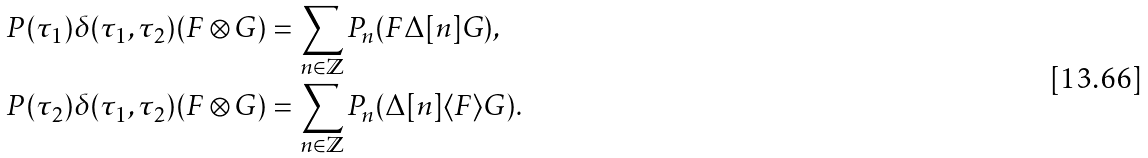<formula> <loc_0><loc_0><loc_500><loc_500>P ( \tau _ { 1 } ) \delta ( \tau _ { 1 } , \tau _ { 2 } ) ( F \otimes G ) & = \sum _ { n \in \mathbb { Z } } P _ { n } ( F \Delta [ n ] G ) , \\ P ( \tau _ { 2 } ) \delta ( \tau _ { 1 } , \tau _ { 2 } ) ( F \otimes G ) & = \sum _ { n \in \mathbb { Z } } P _ { n } ( \Delta [ n ] \langle F \rangle G ) .</formula> 